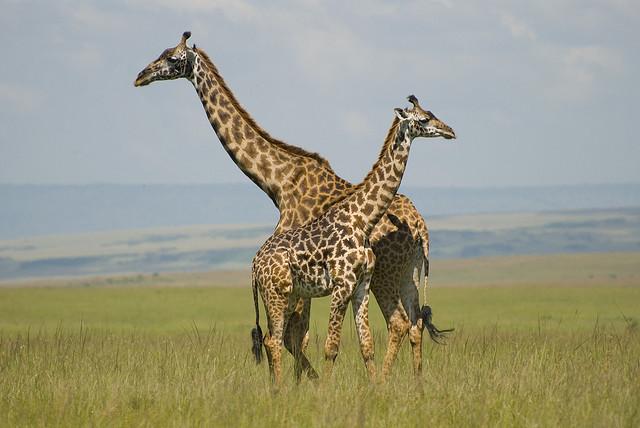Are they allowed to roam free?
Be succinct. Yes. Are the giraffes facing each other?
Short answer required. No. Are the giraffes lonely?
Give a very brief answer. No. Which giraffe is in front?
Keep it brief. Shorter one. What color is the ground covering?
Quick response, please. Green. Are there mountains in the background?
Keep it brief. No. Is there a bird in this picture?
Answer briefly. No. How tall is the grass the giraffes are standing in?
Concise answer only. Knee height. Is the smaller animal a baby?
Short answer required. Yes. 